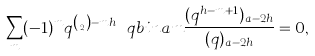Convert formula to latex. <formula><loc_0><loc_0><loc_500><loc_500>\sum _ { m } ( - 1 ) ^ { m } q ^ { \binom { m } { 2 } - m h } \ q b i n { a } { m } \frac { ( q ^ { h - m + 1 } ) _ { a - 2 h } } { ( q ) _ { a - 2 h } } = 0 ,</formula> 